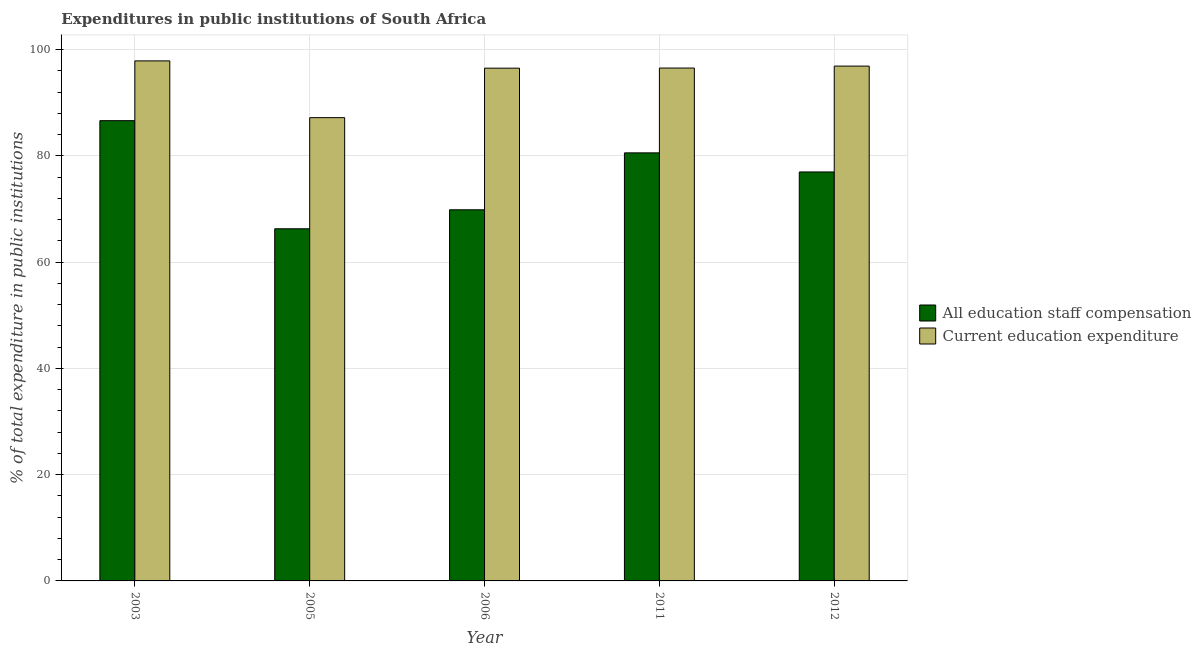Are the number of bars per tick equal to the number of legend labels?
Provide a succinct answer. Yes. Are the number of bars on each tick of the X-axis equal?
Make the answer very short. Yes. How many bars are there on the 2nd tick from the left?
Make the answer very short. 2. How many bars are there on the 4th tick from the right?
Your answer should be compact. 2. What is the label of the 3rd group of bars from the left?
Make the answer very short. 2006. What is the expenditure in staff compensation in 2005?
Your response must be concise. 66.28. Across all years, what is the maximum expenditure in education?
Your answer should be very brief. 97.87. Across all years, what is the minimum expenditure in staff compensation?
Make the answer very short. 66.28. In which year was the expenditure in staff compensation maximum?
Offer a very short reply. 2003. In which year was the expenditure in staff compensation minimum?
Your answer should be very brief. 2005. What is the total expenditure in education in the graph?
Give a very brief answer. 474.97. What is the difference between the expenditure in staff compensation in 2003 and that in 2011?
Offer a very short reply. 6.06. What is the difference between the expenditure in staff compensation in 2005 and the expenditure in education in 2006?
Your answer should be very brief. -3.57. What is the average expenditure in education per year?
Make the answer very short. 94.99. What is the ratio of the expenditure in staff compensation in 2005 to that in 2011?
Your answer should be compact. 0.82. What is the difference between the highest and the second highest expenditure in education?
Your answer should be very brief. 0.98. What is the difference between the highest and the lowest expenditure in education?
Provide a short and direct response. 10.69. In how many years, is the expenditure in staff compensation greater than the average expenditure in staff compensation taken over all years?
Give a very brief answer. 3. Is the sum of the expenditure in education in 2003 and 2011 greater than the maximum expenditure in staff compensation across all years?
Offer a terse response. Yes. What does the 2nd bar from the left in 2003 represents?
Offer a terse response. Current education expenditure. What does the 2nd bar from the right in 2012 represents?
Offer a very short reply. All education staff compensation. What is the difference between two consecutive major ticks on the Y-axis?
Ensure brevity in your answer.  20. How many legend labels are there?
Give a very brief answer. 2. How are the legend labels stacked?
Offer a terse response. Vertical. What is the title of the graph?
Make the answer very short. Expenditures in public institutions of South Africa. Does "Male" appear as one of the legend labels in the graph?
Ensure brevity in your answer.  No. What is the label or title of the Y-axis?
Your answer should be very brief. % of total expenditure in public institutions. What is the % of total expenditure in public institutions in All education staff compensation in 2003?
Offer a very short reply. 86.62. What is the % of total expenditure in public institutions in Current education expenditure in 2003?
Provide a short and direct response. 97.87. What is the % of total expenditure in public institutions in All education staff compensation in 2005?
Provide a succinct answer. 66.28. What is the % of total expenditure in public institutions in Current education expenditure in 2005?
Offer a very short reply. 87.19. What is the % of total expenditure in public institutions in All education staff compensation in 2006?
Keep it short and to the point. 69.85. What is the % of total expenditure in public institutions of Current education expenditure in 2006?
Offer a terse response. 96.5. What is the % of total expenditure in public institutions in All education staff compensation in 2011?
Provide a succinct answer. 80.56. What is the % of total expenditure in public institutions of Current education expenditure in 2011?
Offer a terse response. 96.53. What is the % of total expenditure in public institutions of All education staff compensation in 2012?
Make the answer very short. 76.97. What is the % of total expenditure in public institutions in Current education expenditure in 2012?
Make the answer very short. 96.89. Across all years, what is the maximum % of total expenditure in public institutions of All education staff compensation?
Offer a terse response. 86.62. Across all years, what is the maximum % of total expenditure in public institutions in Current education expenditure?
Your answer should be compact. 97.87. Across all years, what is the minimum % of total expenditure in public institutions in All education staff compensation?
Your answer should be compact. 66.28. Across all years, what is the minimum % of total expenditure in public institutions of Current education expenditure?
Provide a succinct answer. 87.19. What is the total % of total expenditure in public institutions in All education staff compensation in the graph?
Provide a succinct answer. 380.27. What is the total % of total expenditure in public institutions of Current education expenditure in the graph?
Your answer should be compact. 474.97. What is the difference between the % of total expenditure in public institutions of All education staff compensation in 2003 and that in 2005?
Offer a terse response. 20.35. What is the difference between the % of total expenditure in public institutions in Current education expenditure in 2003 and that in 2005?
Your response must be concise. 10.69. What is the difference between the % of total expenditure in public institutions in All education staff compensation in 2003 and that in 2006?
Make the answer very short. 16.77. What is the difference between the % of total expenditure in public institutions of Current education expenditure in 2003 and that in 2006?
Offer a terse response. 1.37. What is the difference between the % of total expenditure in public institutions in All education staff compensation in 2003 and that in 2011?
Ensure brevity in your answer.  6.06. What is the difference between the % of total expenditure in public institutions in Current education expenditure in 2003 and that in 2011?
Keep it short and to the point. 1.35. What is the difference between the % of total expenditure in public institutions of All education staff compensation in 2003 and that in 2012?
Offer a very short reply. 9.65. What is the difference between the % of total expenditure in public institutions in Current education expenditure in 2003 and that in 2012?
Ensure brevity in your answer.  0.98. What is the difference between the % of total expenditure in public institutions of All education staff compensation in 2005 and that in 2006?
Offer a terse response. -3.57. What is the difference between the % of total expenditure in public institutions in Current education expenditure in 2005 and that in 2006?
Offer a terse response. -9.31. What is the difference between the % of total expenditure in public institutions of All education staff compensation in 2005 and that in 2011?
Ensure brevity in your answer.  -14.28. What is the difference between the % of total expenditure in public institutions in Current education expenditure in 2005 and that in 2011?
Give a very brief answer. -9.34. What is the difference between the % of total expenditure in public institutions of All education staff compensation in 2005 and that in 2012?
Make the answer very short. -10.69. What is the difference between the % of total expenditure in public institutions of Current education expenditure in 2005 and that in 2012?
Keep it short and to the point. -9.7. What is the difference between the % of total expenditure in public institutions in All education staff compensation in 2006 and that in 2011?
Your answer should be very brief. -10.71. What is the difference between the % of total expenditure in public institutions of Current education expenditure in 2006 and that in 2011?
Your answer should be compact. -0.03. What is the difference between the % of total expenditure in public institutions in All education staff compensation in 2006 and that in 2012?
Keep it short and to the point. -7.12. What is the difference between the % of total expenditure in public institutions in Current education expenditure in 2006 and that in 2012?
Your response must be concise. -0.39. What is the difference between the % of total expenditure in public institutions in All education staff compensation in 2011 and that in 2012?
Make the answer very short. 3.59. What is the difference between the % of total expenditure in public institutions in Current education expenditure in 2011 and that in 2012?
Your answer should be very brief. -0.36. What is the difference between the % of total expenditure in public institutions of All education staff compensation in 2003 and the % of total expenditure in public institutions of Current education expenditure in 2005?
Your answer should be very brief. -0.57. What is the difference between the % of total expenditure in public institutions of All education staff compensation in 2003 and the % of total expenditure in public institutions of Current education expenditure in 2006?
Give a very brief answer. -9.88. What is the difference between the % of total expenditure in public institutions in All education staff compensation in 2003 and the % of total expenditure in public institutions in Current education expenditure in 2011?
Your answer should be very brief. -9.9. What is the difference between the % of total expenditure in public institutions of All education staff compensation in 2003 and the % of total expenditure in public institutions of Current education expenditure in 2012?
Provide a succinct answer. -10.27. What is the difference between the % of total expenditure in public institutions of All education staff compensation in 2005 and the % of total expenditure in public institutions of Current education expenditure in 2006?
Make the answer very short. -30.22. What is the difference between the % of total expenditure in public institutions of All education staff compensation in 2005 and the % of total expenditure in public institutions of Current education expenditure in 2011?
Make the answer very short. -30.25. What is the difference between the % of total expenditure in public institutions in All education staff compensation in 2005 and the % of total expenditure in public institutions in Current education expenditure in 2012?
Give a very brief answer. -30.61. What is the difference between the % of total expenditure in public institutions of All education staff compensation in 2006 and the % of total expenditure in public institutions of Current education expenditure in 2011?
Provide a short and direct response. -26.68. What is the difference between the % of total expenditure in public institutions of All education staff compensation in 2006 and the % of total expenditure in public institutions of Current education expenditure in 2012?
Give a very brief answer. -27.04. What is the difference between the % of total expenditure in public institutions of All education staff compensation in 2011 and the % of total expenditure in public institutions of Current education expenditure in 2012?
Give a very brief answer. -16.33. What is the average % of total expenditure in public institutions of All education staff compensation per year?
Provide a short and direct response. 76.05. What is the average % of total expenditure in public institutions in Current education expenditure per year?
Your answer should be very brief. 94.99. In the year 2003, what is the difference between the % of total expenditure in public institutions in All education staff compensation and % of total expenditure in public institutions in Current education expenditure?
Keep it short and to the point. -11.25. In the year 2005, what is the difference between the % of total expenditure in public institutions in All education staff compensation and % of total expenditure in public institutions in Current education expenditure?
Make the answer very short. -20.91. In the year 2006, what is the difference between the % of total expenditure in public institutions in All education staff compensation and % of total expenditure in public institutions in Current education expenditure?
Keep it short and to the point. -26.65. In the year 2011, what is the difference between the % of total expenditure in public institutions in All education staff compensation and % of total expenditure in public institutions in Current education expenditure?
Give a very brief answer. -15.97. In the year 2012, what is the difference between the % of total expenditure in public institutions in All education staff compensation and % of total expenditure in public institutions in Current education expenditure?
Ensure brevity in your answer.  -19.92. What is the ratio of the % of total expenditure in public institutions of All education staff compensation in 2003 to that in 2005?
Your answer should be very brief. 1.31. What is the ratio of the % of total expenditure in public institutions in Current education expenditure in 2003 to that in 2005?
Offer a very short reply. 1.12. What is the ratio of the % of total expenditure in public institutions of All education staff compensation in 2003 to that in 2006?
Your response must be concise. 1.24. What is the ratio of the % of total expenditure in public institutions in Current education expenditure in 2003 to that in 2006?
Make the answer very short. 1.01. What is the ratio of the % of total expenditure in public institutions of All education staff compensation in 2003 to that in 2011?
Your response must be concise. 1.08. What is the ratio of the % of total expenditure in public institutions in All education staff compensation in 2003 to that in 2012?
Make the answer very short. 1.13. What is the ratio of the % of total expenditure in public institutions of Current education expenditure in 2003 to that in 2012?
Your answer should be very brief. 1.01. What is the ratio of the % of total expenditure in public institutions in All education staff compensation in 2005 to that in 2006?
Ensure brevity in your answer.  0.95. What is the ratio of the % of total expenditure in public institutions in Current education expenditure in 2005 to that in 2006?
Provide a short and direct response. 0.9. What is the ratio of the % of total expenditure in public institutions of All education staff compensation in 2005 to that in 2011?
Offer a terse response. 0.82. What is the ratio of the % of total expenditure in public institutions of Current education expenditure in 2005 to that in 2011?
Your answer should be very brief. 0.9. What is the ratio of the % of total expenditure in public institutions in All education staff compensation in 2005 to that in 2012?
Provide a short and direct response. 0.86. What is the ratio of the % of total expenditure in public institutions of Current education expenditure in 2005 to that in 2012?
Your answer should be compact. 0.9. What is the ratio of the % of total expenditure in public institutions of All education staff compensation in 2006 to that in 2011?
Make the answer very short. 0.87. What is the ratio of the % of total expenditure in public institutions of All education staff compensation in 2006 to that in 2012?
Provide a short and direct response. 0.91. What is the ratio of the % of total expenditure in public institutions of All education staff compensation in 2011 to that in 2012?
Your answer should be very brief. 1.05. What is the ratio of the % of total expenditure in public institutions in Current education expenditure in 2011 to that in 2012?
Ensure brevity in your answer.  1. What is the difference between the highest and the second highest % of total expenditure in public institutions of All education staff compensation?
Your response must be concise. 6.06. What is the difference between the highest and the second highest % of total expenditure in public institutions of Current education expenditure?
Your answer should be very brief. 0.98. What is the difference between the highest and the lowest % of total expenditure in public institutions in All education staff compensation?
Ensure brevity in your answer.  20.35. What is the difference between the highest and the lowest % of total expenditure in public institutions of Current education expenditure?
Make the answer very short. 10.69. 